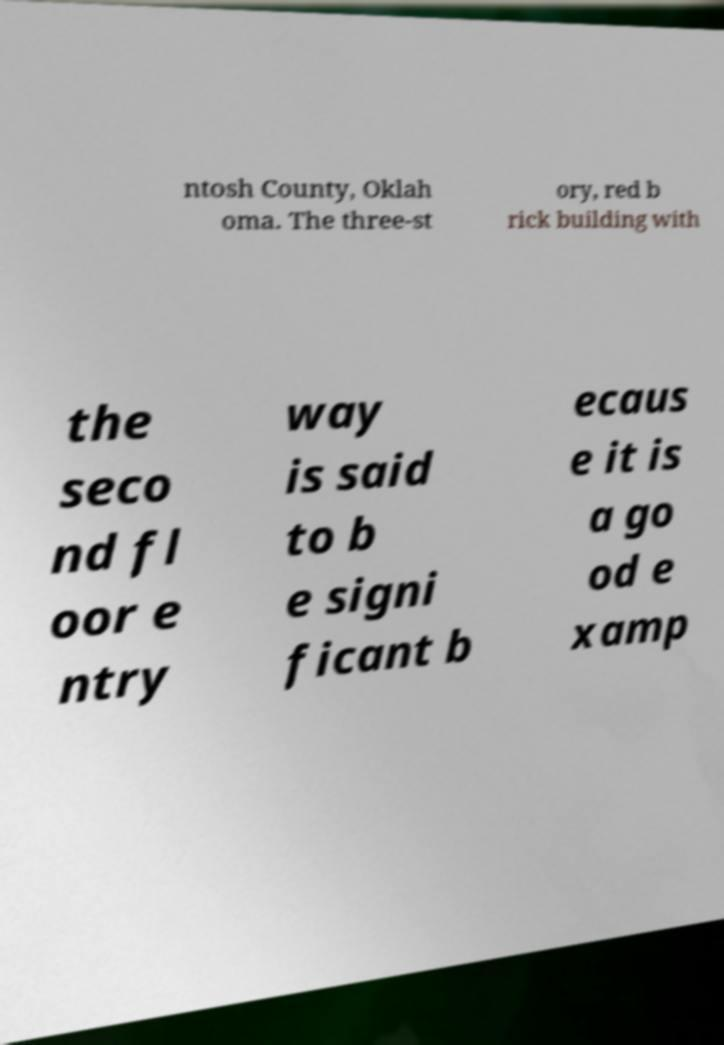Could you extract and type out the text from this image? ntosh County, Oklah oma. The three-st ory, red b rick building with the seco nd fl oor e ntry way is said to b e signi ficant b ecaus e it is a go od e xamp 